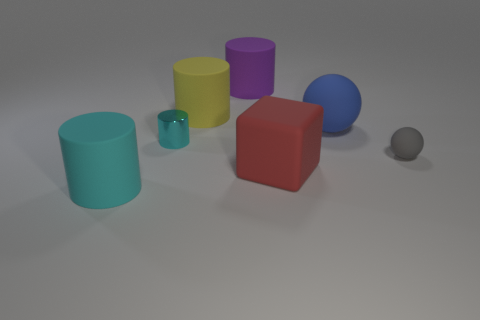Subtract all shiny cylinders. How many cylinders are left? 3 Subtract all cyan balls. How many cyan cylinders are left? 2 Subtract all blue spheres. How many spheres are left? 1 Add 2 big purple matte cylinders. How many objects exist? 9 Add 7 large yellow cylinders. How many large yellow cylinders exist? 8 Subtract 0 yellow blocks. How many objects are left? 7 Subtract all cubes. How many objects are left? 6 Subtract all purple spheres. Subtract all blue cylinders. How many spheres are left? 2 Subtract all blue things. Subtract all red objects. How many objects are left? 5 Add 4 large yellow matte things. How many large yellow matte things are left? 5 